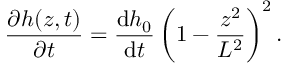Convert formula to latex. <formula><loc_0><loc_0><loc_500><loc_500>\frac { \partial h ( z , t ) } { \partial t } = \frac { d h _ { 0 } } { d t } \left ( 1 - \frac { z ^ { 2 } } { L ^ { 2 } } \right ) ^ { 2 } .</formula> 